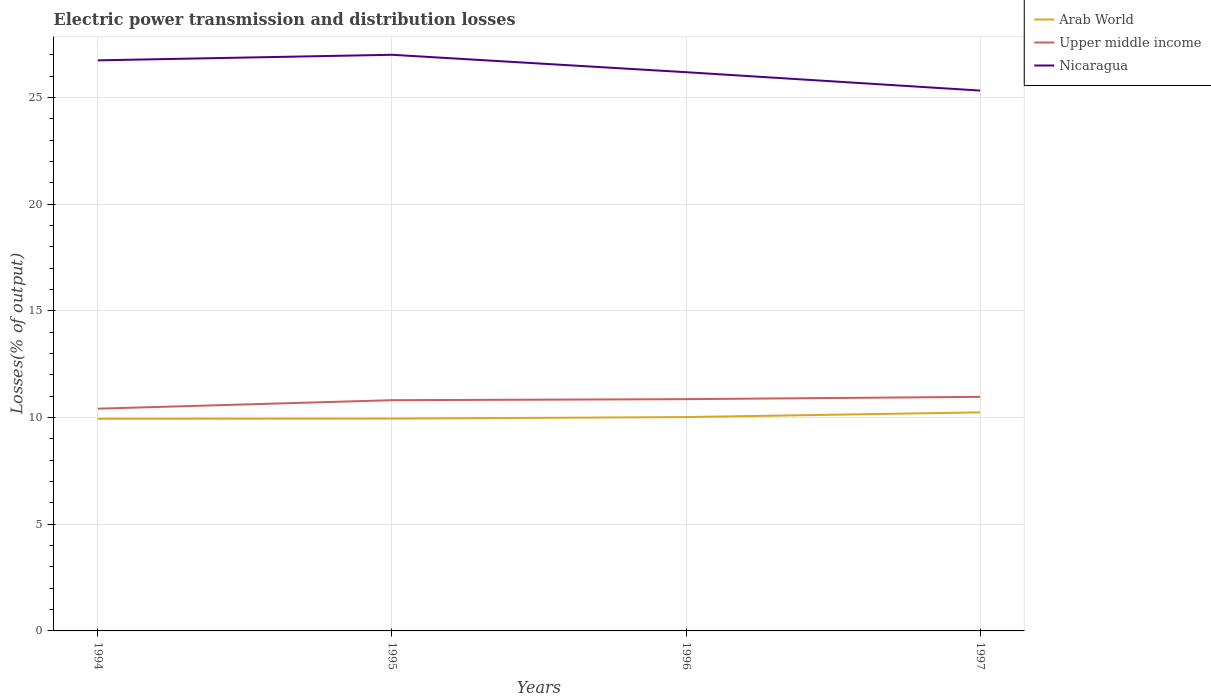How many different coloured lines are there?
Ensure brevity in your answer.  3. Is the number of lines equal to the number of legend labels?
Provide a succinct answer. Yes. Across all years, what is the maximum electric power transmission and distribution losses in Upper middle income?
Provide a succinct answer. 10.42. What is the total electric power transmission and distribution losses in Upper middle income in the graph?
Your answer should be very brief. -0.11. What is the difference between the highest and the second highest electric power transmission and distribution losses in Nicaragua?
Keep it short and to the point. 1.68. What is the difference between the highest and the lowest electric power transmission and distribution losses in Nicaragua?
Offer a terse response. 2. Is the electric power transmission and distribution losses in Arab World strictly greater than the electric power transmission and distribution losses in Nicaragua over the years?
Your answer should be very brief. Yes. How many years are there in the graph?
Your response must be concise. 4. What is the difference between two consecutive major ticks on the Y-axis?
Your response must be concise. 5. Are the values on the major ticks of Y-axis written in scientific E-notation?
Keep it short and to the point. No. Where does the legend appear in the graph?
Offer a very short reply. Top right. How many legend labels are there?
Ensure brevity in your answer.  3. What is the title of the graph?
Your answer should be compact. Electric power transmission and distribution losses. Does "Marshall Islands" appear as one of the legend labels in the graph?
Your answer should be compact. No. What is the label or title of the Y-axis?
Keep it short and to the point. Losses(% of output). What is the Losses(% of output) of Arab World in 1994?
Offer a terse response. 9.94. What is the Losses(% of output) of Upper middle income in 1994?
Keep it short and to the point. 10.42. What is the Losses(% of output) in Nicaragua in 1994?
Provide a succinct answer. 26.75. What is the Losses(% of output) of Arab World in 1995?
Your answer should be very brief. 9.95. What is the Losses(% of output) of Upper middle income in 1995?
Ensure brevity in your answer.  10.82. What is the Losses(% of output) in Nicaragua in 1995?
Your answer should be compact. 27.01. What is the Losses(% of output) in Arab World in 1996?
Offer a terse response. 10.02. What is the Losses(% of output) in Upper middle income in 1996?
Make the answer very short. 10.86. What is the Losses(% of output) in Nicaragua in 1996?
Provide a succinct answer. 26.19. What is the Losses(% of output) in Arab World in 1997?
Your response must be concise. 10.25. What is the Losses(% of output) of Upper middle income in 1997?
Your answer should be compact. 10.97. What is the Losses(% of output) in Nicaragua in 1997?
Make the answer very short. 25.33. Across all years, what is the maximum Losses(% of output) in Arab World?
Give a very brief answer. 10.25. Across all years, what is the maximum Losses(% of output) of Upper middle income?
Make the answer very short. 10.97. Across all years, what is the maximum Losses(% of output) of Nicaragua?
Give a very brief answer. 27.01. Across all years, what is the minimum Losses(% of output) of Arab World?
Offer a terse response. 9.94. Across all years, what is the minimum Losses(% of output) of Upper middle income?
Offer a terse response. 10.42. Across all years, what is the minimum Losses(% of output) of Nicaragua?
Offer a very short reply. 25.33. What is the total Losses(% of output) in Arab World in the graph?
Keep it short and to the point. 40.17. What is the total Losses(% of output) of Upper middle income in the graph?
Offer a terse response. 43.07. What is the total Losses(% of output) of Nicaragua in the graph?
Your answer should be very brief. 105.28. What is the difference between the Losses(% of output) of Arab World in 1994 and that in 1995?
Your response must be concise. -0.01. What is the difference between the Losses(% of output) of Upper middle income in 1994 and that in 1995?
Offer a terse response. -0.4. What is the difference between the Losses(% of output) in Nicaragua in 1994 and that in 1995?
Keep it short and to the point. -0.26. What is the difference between the Losses(% of output) of Arab World in 1994 and that in 1996?
Offer a terse response. -0.08. What is the difference between the Losses(% of output) of Upper middle income in 1994 and that in 1996?
Provide a short and direct response. -0.45. What is the difference between the Losses(% of output) of Nicaragua in 1994 and that in 1996?
Give a very brief answer. 0.56. What is the difference between the Losses(% of output) of Arab World in 1994 and that in 1997?
Keep it short and to the point. -0.3. What is the difference between the Losses(% of output) of Upper middle income in 1994 and that in 1997?
Your response must be concise. -0.55. What is the difference between the Losses(% of output) in Nicaragua in 1994 and that in 1997?
Ensure brevity in your answer.  1.42. What is the difference between the Losses(% of output) in Arab World in 1995 and that in 1996?
Your response must be concise. -0.07. What is the difference between the Losses(% of output) in Upper middle income in 1995 and that in 1996?
Keep it short and to the point. -0.05. What is the difference between the Losses(% of output) in Nicaragua in 1995 and that in 1996?
Make the answer very short. 0.82. What is the difference between the Losses(% of output) in Arab World in 1995 and that in 1997?
Offer a very short reply. -0.29. What is the difference between the Losses(% of output) in Upper middle income in 1995 and that in 1997?
Provide a succinct answer. -0.16. What is the difference between the Losses(% of output) of Nicaragua in 1995 and that in 1997?
Make the answer very short. 1.68. What is the difference between the Losses(% of output) of Arab World in 1996 and that in 1997?
Provide a succinct answer. -0.22. What is the difference between the Losses(% of output) in Upper middle income in 1996 and that in 1997?
Offer a terse response. -0.11. What is the difference between the Losses(% of output) of Nicaragua in 1996 and that in 1997?
Offer a terse response. 0.86. What is the difference between the Losses(% of output) of Arab World in 1994 and the Losses(% of output) of Upper middle income in 1995?
Keep it short and to the point. -0.87. What is the difference between the Losses(% of output) of Arab World in 1994 and the Losses(% of output) of Nicaragua in 1995?
Give a very brief answer. -17.06. What is the difference between the Losses(% of output) in Upper middle income in 1994 and the Losses(% of output) in Nicaragua in 1995?
Give a very brief answer. -16.59. What is the difference between the Losses(% of output) in Arab World in 1994 and the Losses(% of output) in Upper middle income in 1996?
Provide a short and direct response. -0.92. What is the difference between the Losses(% of output) of Arab World in 1994 and the Losses(% of output) of Nicaragua in 1996?
Your answer should be compact. -16.25. What is the difference between the Losses(% of output) of Upper middle income in 1994 and the Losses(% of output) of Nicaragua in 1996?
Provide a succinct answer. -15.77. What is the difference between the Losses(% of output) of Arab World in 1994 and the Losses(% of output) of Upper middle income in 1997?
Ensure brevity in your answer.  -1.03. What is the difference between the Losses(% of output) in Arab World in 1994 and the Losses(% of output) in Nicaragua in 1997?
Your answer should be very brief. -15.39. What is the difference between the Losses(% of output) in Upper middle income in 1994 and the Losses(% of output) in Nicaragua in 1997?
Keep it short and to the point. -14.91. What is the difference between the Losses(% of output) in Arab World in 1995 and the Losses(% of output) in Upper middle income in 1996?
Offer a very short reply. -0.91. What is the difference between the Losses(% of output) in Arab World in 1995 and the Losses(% of output) in Nicaragua in 1996?
Offer a terse response. -16.24. What is the difference between the Losses(% of output) in Upper middle income in 1995 and the Losses(% of output) in Nicaragua in 1996?
Offer a terse response. -15.38. What is the difference between the Losses(% of output) of Arab World in 1995 and the Losses(% of output) of Upper middle income in 1997?
Your answer should be very brief. -1.02. What is the difference between the Losses(% of output) in Arab World in 1995 and the Losses(% of output) in Nicaragua in 1997?
Offer a terse response. -15.38. What is the difference between the Losses(% of output) of Upper middle income in 1995 and the Losses(% of output) of Nicaragua in 1997?
Your answer should be very brief. -14.51. What is the difference between the Losses(% of output) of Arab World in 1996 and the Losses(% of output) of Upper middle income in 1997?
Provide a succinct answer. -0.95. What is the difference between the Losses(% of output) of Arab World in 1996 and the Losses(% of output) of Nicaragua in 1997?
Ensure brevity in your answer.  -15.31. What is the difference between the Losses(% of output) in Upper middle income in 1996 and the Losses(% of output) in Nicaragua in 1997?
Keep it short and to the point. -14.47. What is the average Losses(% of output) in Arab World per year?
Give a very brief answer. 10.04. What is the average Losses(% of output) in Upper middle income per year?
Offer a very short reply. 10.77. What is the average Losses(% of output) of Nicaragua per year?
Your response must be concise. 26.32. In the year 1994, what is the difference between the Losses(% of output) of Arab World and Losses(% of output) of Upper middle income?
Offer a terse response. -0.47. In the year 1994, what is the difference between the Losses(% of output) in Arab World and Losses(% of output) in Nicaragua?
Offer a terse response. -16.8. In the year 1994, what is the difference between the Losses(% of output) of Upper middle income and Losses(% of output) of Nicaragua?
Keep it short and to the point. -16.33. In the year 1995, what is the difference between the Losses(% of output) in Arab World and Losses(% of output) in Upper middle income?
Offer a terse response. -0.86. In the year 1995, what is the difference between the Losses(% of output) in Arab World and Losses(% of output) in Nicaragua?
Give a very brief answer. -17.05. In the year 1995, what is the difference between the Losses(% of output) in Upper middle income and Losses(% of output) in Nicaragua?
Offer a terse response. -16.19. In the year 1996, what is the difference between the Losses(% of output) in Arab World and Losses(% of output) in Upper middle income?
Offer a very short reply. -0.84. In the year 1996, what is the difference between the Losses(% of output) of Arab World and Losses(% of output) of Nicaragua?
Provide a succinct answer. -16.17. In the year 1996, what is the difference between the Losses(% of output) in Upper middle income and Losses(% of output) in Nicaragua?
Offer a terse response. -15.33. In the year 1997, what is the difference between the Losses(% of output) in Arab World and Losses(% of output) in Upper middle income?
Keep it short and to the point. -0.73. In the year 1997, what is the difference between the Losses(% of output) in Arab World and Losses(% of output) in Nicaragua?
Ensure brevity in your answer.  -15.08. In the year 1997, what is the difference between the Losses(% of output) in Upper middle income and Losses(% of output) in Nicaragua?
Offer a very short reply. -14.36. What is the ratio of the Losses(% of output) of Arab World in 1994 to that in 1995?
Offer a very short reply. 1. What is the ratio of the Losses(% of output) of Upper middle income in 1994 to that in 1995?
Keep it short and to the point. 0.96. What is the ratio of the Losses(% of output) in Nicaragua in 1994 to that in 1995?
Offer a very short reply. 0.99. What is the ratio of the Losses(% of output) of Arab World in 1994 to that in 1996?
Ensure brevity in your answer.  0.99. What is the ratio of the Losses(% of output) of Upper middle income in 1994 to that in 1996?
Keep it short and to the point. 0.96. What is the ratio of the Losses(% of output) of Nicaragua in 1994 to that in 1996?
Make the answer very short. 1.02. What is the ratio of the Losses(% of output) in Arab World in 1994 to that in 1997?
Offer a very short reply. 0.97. What is the ratio of the Losses(% of output) in Upper middle income in 1994 to that in 1997?
Your answer should be very brief. 0.95. What is the ratio of the Losses(% of output) in Nicaragua in 1994 to that in 1997?
Your answer should be compact. 1.06. What is the ratio of the Losses(% of output) of Arab World in 1995 to that in 1996?
Make the answer very short. 0.99. What is the ratio of the Losses(% of output) of Upper middle income in 1995 to that in 1996?
Your response must be concise. 1. What is the ratio of the Losses(% of output) of Nicaragua in 1995 to that in 1996?
Provide a short and direct response. 1.03. What is the ratio of the Losses(% of output) in Arab World in 1995 to that in 1997?
Ensure brevity in your answer.  0.97. What is the ratio of the Losses(% of output) of Upper middle income in 1995 to that in 1997?
Make the answer very short. 0.99. What is the ratio of the Losses(% of output) in Nicaragua in 1995 to that in 1997?
Provide a short and direct response. 1.07. What is the ratio of the Losses(% of output) of Arab World in 1996 to that in 1997?
Provide a succinct answer. 0.98. What is the ratio of the Losses(% of output) of Nicaragua in 1996 to that in 1997?
Offer a terse response. 1.03. What is the difference between the highest and the second highest Losses(% of output) in Arab World?
Provide a short and direct response. 0.22. What is the difference between the highest and the second highest Losses(% of output) in Upper middle income?
Offer a very short reply. 0.11. What is the difference between the highest and the second highest Losses(% of output) of Nicaragua?
Provide a succinct answer. 0.26. What is the difference between the highest and the lowest Losses(% of output) in Arab World?
Provide a short and direct response. 0.3. What is the difference between the highest and the lowest Losses(% of output) of Upper middle income?
Make the answer very short. 0.55. What is the difference between the highest and the lowest Losses(% of output) of Nicaragua?
Provide a short and direct response. 1.68. 